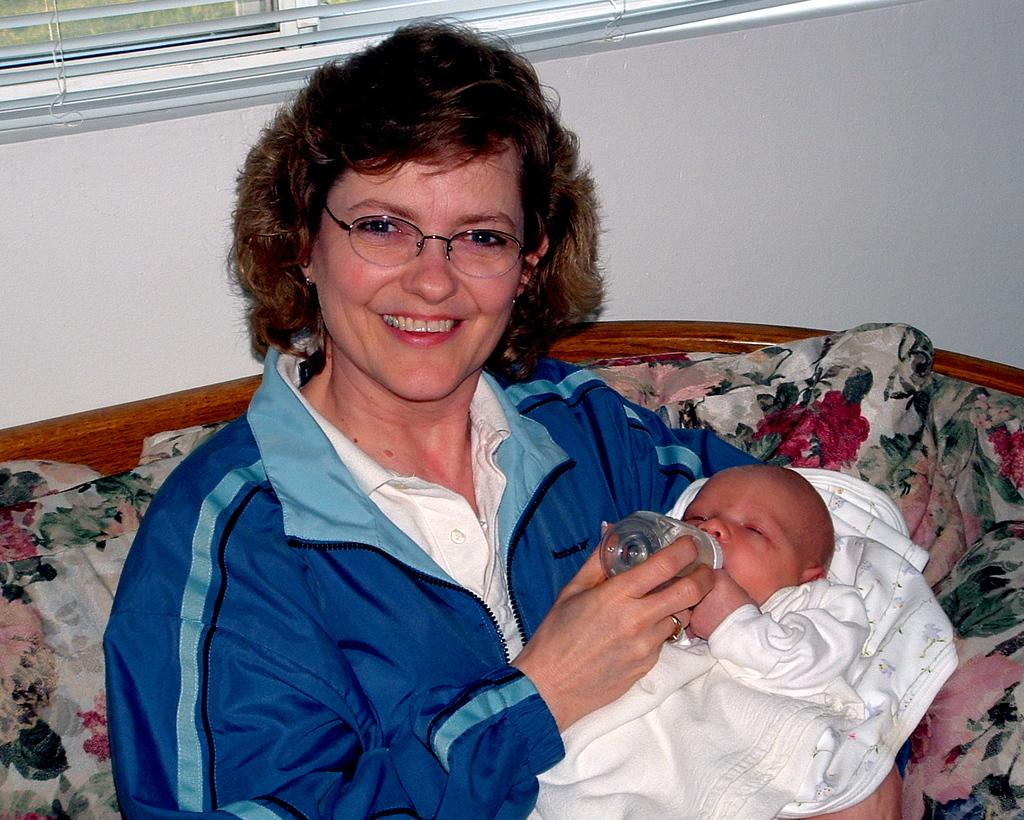Who is in the image? There is a woman in the image. What is the woman wearing? The woman is wearing a blue jacket. What is the woman doing with the kid? The woman is holding a kid and feeding the baby. What type of furniture is in the image? There is a sofa in the image. What is covering the window? There is a window blind in the image. What is the background of the image made of? There is a wall in the image. What type of drink is the woman holding in the image? There is no drink visible in the image; the woman is feeding the baby. 